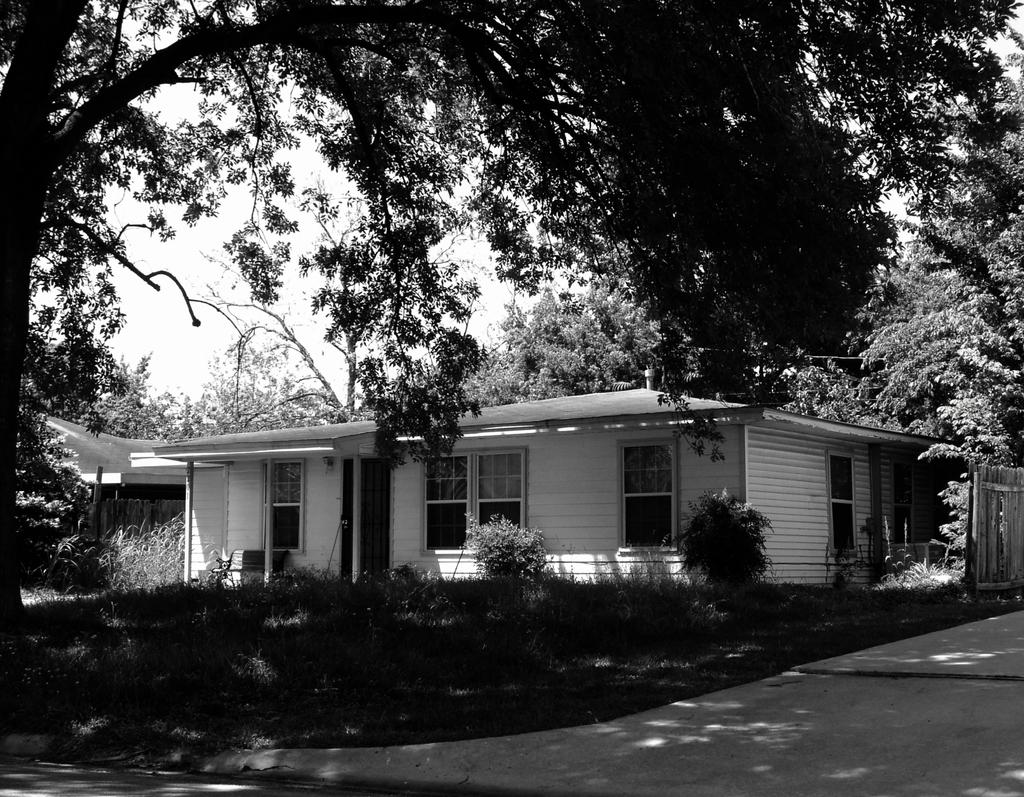What type of structure is present in the image? There is a building in the image. What can be seen on the ground in the image? There are plants on the ground in the image. What type of vegetation is visible in the image? There are trees in the image. What is visible at the top of the image? The sky is visible at the top of the image. What type of blood is visible on the building in the image? There is no blood visible on the building in the image. 